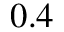Convert formula to latex. <formula><loc_0><loc_0><loc_500><loc_500>0 . 4</formula> 